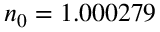<formula> <loc_0><loc_0><loc_500><loc_500>n _ { 0 } = 1 . 0 0 0 2 7 9</formula> 